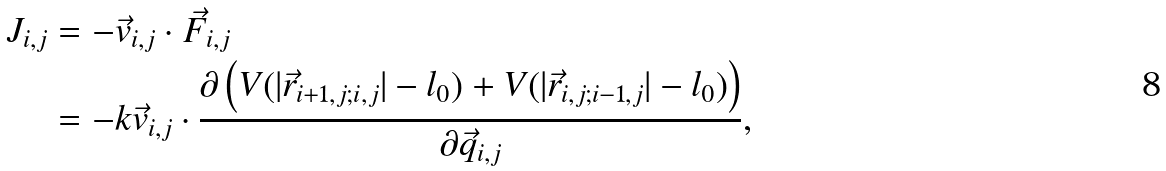Convert formula to latex. <formula><loc_0><loc_0><loc_500><loc_500>J _ { i , j } & = - \vec { v } _ { i , j } \cdot \vec { F } _ { i , j } \\ & = - k \vec { v } _ { i , j } \cdot \frac { \partial \left ( V ( | \vec { r } _ { i + 1 , j ; i , j } | - l _ { 0 } ) + V ( | \vec { r } _ { i , j ; i - 1 , j } | - l _ { 0 } ) \right ) } { \partial \vec { q } _ { i , j } } ,</formula> 